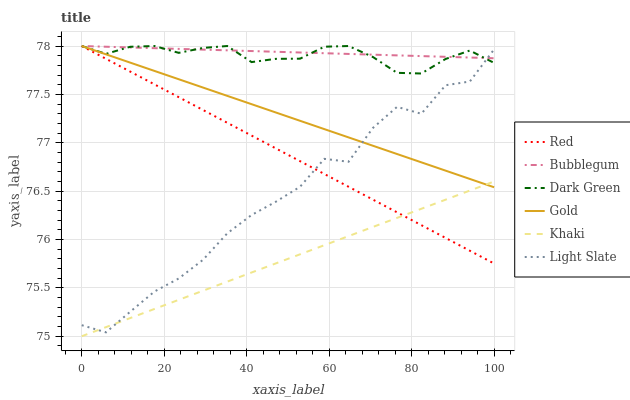Does Khaki have the minimum area under the curve?
Answer yes or no. Yes. Does Bubblegum have the maximum area under the curve?
Answer yes or no. Yes. Does Gold have the minimum area under the curve?
Answer yes or no. No. Does Gold have the maximum area under the curve?
Answer yes or no. No. Is Bubblegum the smoothest?
Answer yes or no. Yes. Is Light Slate the roughest?
Answer yes or no. Yes. Is Gold the smoothest?
Answer yes or no. No. Is Gold the roughest?
Answer yes or no. No. Does Gold have the lowest value?
Answer yes or no. No. Does Dark Green have the highest value?
Answer yes or no. Yes. Does Light Slate have the highest value?
Answer yes or no. No. Is Khaki less than Bubblegum?
Answer yes or no. Yes. Is Dark Green greater than Khaki?
Answer yes or no. Yes. Does Bubblegum intersect Red?
Answer yes or no. Yes. Is Bubblegum less than Red?
Answer yes or no. No. Is Bubblegum greater than Red?
Answer yes or no. No. Does Khaki intersect Bubblegum?
Answer yes or no. No. 